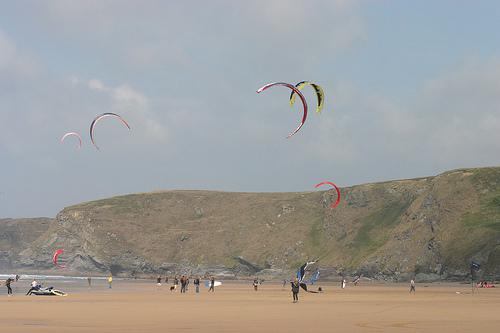Question: what is the sky like?
Choices:
A. Very cloudy.
B. Clear.
C. Very clear.
D. Partly cloudy.
Answer with the letter. Answer: D Question: where is this scene?
Choices:
A. Forest.
B. Jungle.
C. Beach.
D. Field.
Answer with the letter. Answer: C Question: what are they flying?
Choices:
A. Planes.
B. Kites.
C. Helicopters.
D. Gliders.
Answer with the letter. Answer: B 